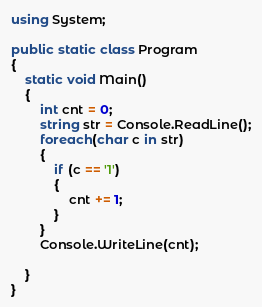Convert code to text. <code><loc_0><loc_0><loc_500><loc_500><_C#_>using System;

public static class Program
{
    static void Main()
    {
        int cnt = 0;
        string str = Console.ReadLine();
        foreach(char c in str)
        {
            if (c == '1')
            {
                cnt += 1;
            }
        }
        Console.WriteLine(cnt);
    
    }
}</code> 